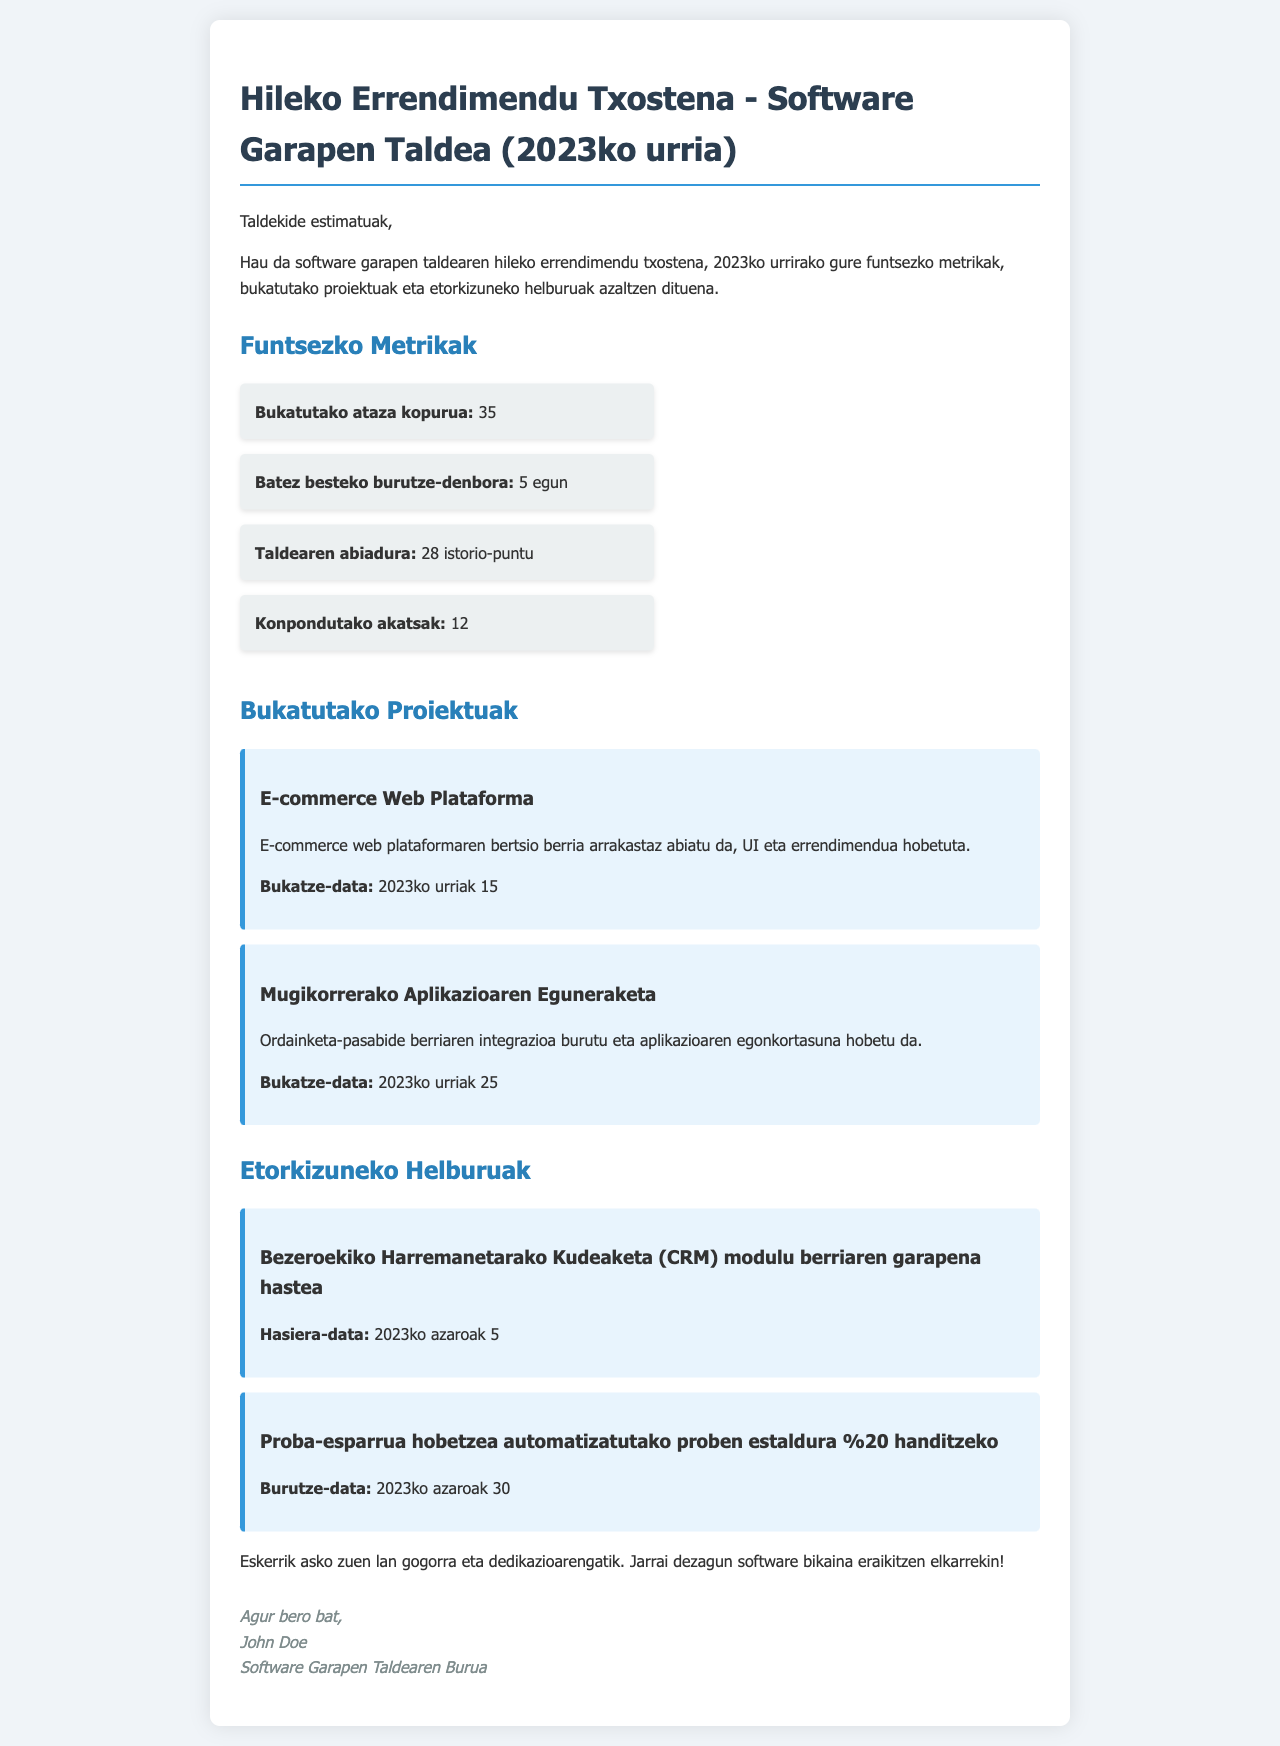What is the total number of completed tasks? The document states that the total number of completed tasks is explicitly mentioned in the key metrics section.
Answer: 35 What is the average completion time? The document provides the average completion time in days within the key metrics.
Answer: 5 egun How many story points did the team complete? The document lists the team’s velocity as a specific number of story points in the metrics section.
Answer: 28 istorio-puntu How many bugs were fixed? The number of resolved bugs is indicated in the key metrics section of the document.
Answer: 12 What is the title of the first completed project? The document specifies the title of the first completed project under the completed projects section.
Answer: E-commerce Web Plataforma When was the e-commerce web platform completed? The completion date of the e-commerce web platform is detailed in the completed projects section.
Answer: 2023ko urriak 15 What is the first future goal mentioned? The document outlines future goals and the first one listed provides an indication of what is planned next.
Answer: Bezeroekiko Harremanetarako Kudeaketa (CRM) modulu berriaren garapena hastea When does the next project start? The start date of the next project is explicitly mentioned in the future goals section.
Answer: 2023ko azaroak 5 What is the goal related to the testing framework? The document outlines a specific goal regarding the testing framework in the future goals section.
Answer: Proba-esparrua hobetzea automatizatutako proben estaldura %20 handitzeko 